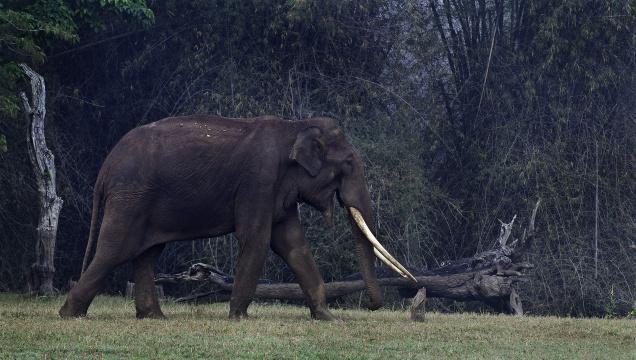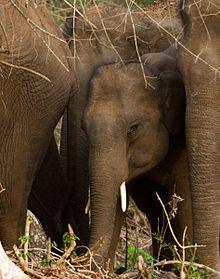The first image is the image on the left, the second image is the image on the right. Analyze the images presented: Is the assertion "At baby elephant is near at least 1 other grown elephant." valid? Answer yes or no. Yes. 